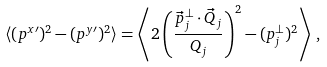Convert formula to latex. <formula><loc_0><loc_0><loc_500><loc_500>\langle ( p ^ { x \prime } ) ^ { 2 } - ( p ^ { y \prime } ) ^ { 2 } \rangle = \left \langle 2 \left ( \frac { \vec { p } _ { j } ^ { \perp } \cdot \vec { Q } _ { j } } { Q _ { j } } \right ) ^ { 2 } - ( p _ { j } ^ { \perp } ) ^ { 2 } \right \rangle \, ,</formula> 